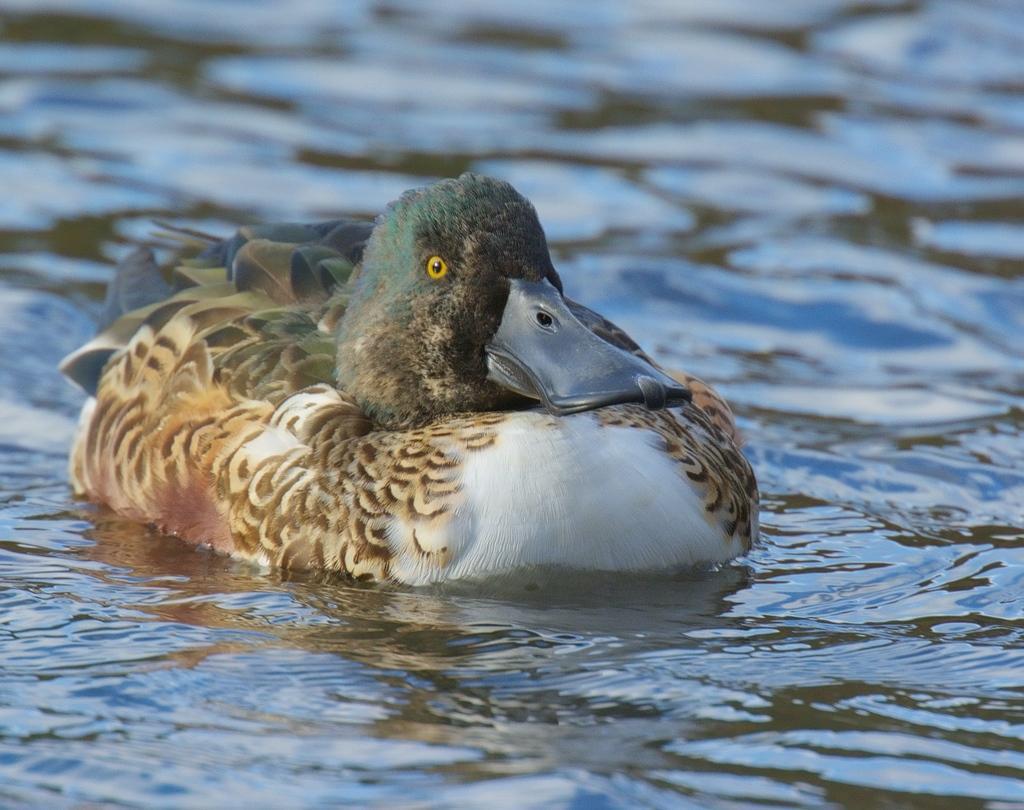How would you summarize this image in a sentence or two? In this picture there is water. In the center of the picture there is a duck. 